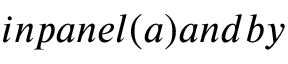<formula> <loc_0><loc_0><loc_500><loc_500>i n p a n e l ( a ) a n d b y</formula> 